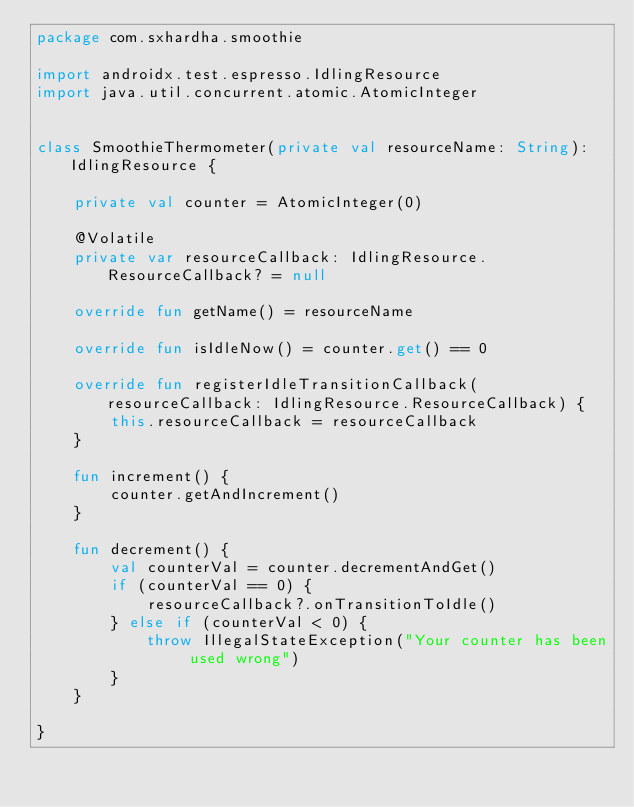<code> <loc_0><loc_0><loc_500><loc_500><_Kotlin_>package com.sxhardha.smoothie

import androidx.test.espresso.IdlingResource
import java.util.concurrent.atomic.AtomicInteger


class SmoothieThermometer(private val resourceName: String): IdlingResource {

    private val counter = AtomicInteger(0)

    @Volatile
    private var resourceCallback: IdlingResource.ResourceCallback? = null

    override fun getName() = resourceName

    override fun isIdleNow() = counter.get() == 0

    override fun registerIdleTransitionCallback(resourceCallback: IdlingResource.ResourceCallback) {
        this.resourceCallback = resourceCallback
    }

    fun increment() {
        counter.getAndIncrement()
    }

    fun decrement() {
        val counterVal = counter.decrementAndGet()
        if (counterVal == 0) {
            resourceCallback?.onTransitionToIdle()
        } else if (counterVal < 0) {
            throw IllegalStateException("Your counter has been used wrong")
        }
    }

}</code> 